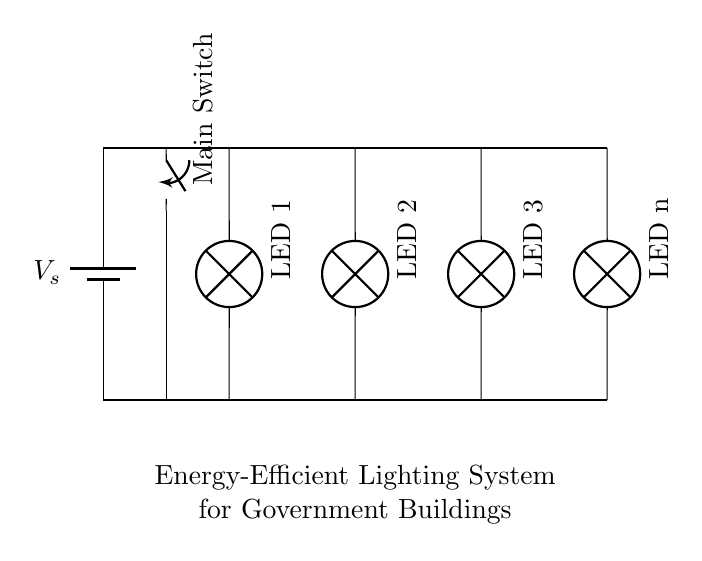What is the power source in this circuit? The power source is a battery, indicated by the symbol in the top left corner of the circuit. It provides the necessary energy for the circuit to function.
Answer: battery How many LED lights are connected in this circuit? There are three visible LED lights labeled LED 1, LED 2, and LED 3, plus one additional LED labeled "LED n" that indicates further LEDs can be added.
Answer: four What is the function of the main switch? The main switch controls the entire circuit, allowing the user to toggle the system on or off. This is indicated by its position in the circuit, placed before the LEDs.
Answer: controls power How are the LEDs connected in this circuit? The LEDs are connected in parallel, meaning each LED has its own direct path to the power source. This allows them to operate independently of each other.
Answer: parallel If one LED fails, how does it affect the others? If one LED fails, the others remain lit because of the parallel configuration, which maintains their independent pathways to the voltage source.
Answer: unaffected What is the overall purpose of this circuit? The overall purpose is to provide an energy-efficient lighting system for government buildings managed through the main switch. This is indicated by the label at the bottom of the circuit.
Answer: energy-efficient lighting 